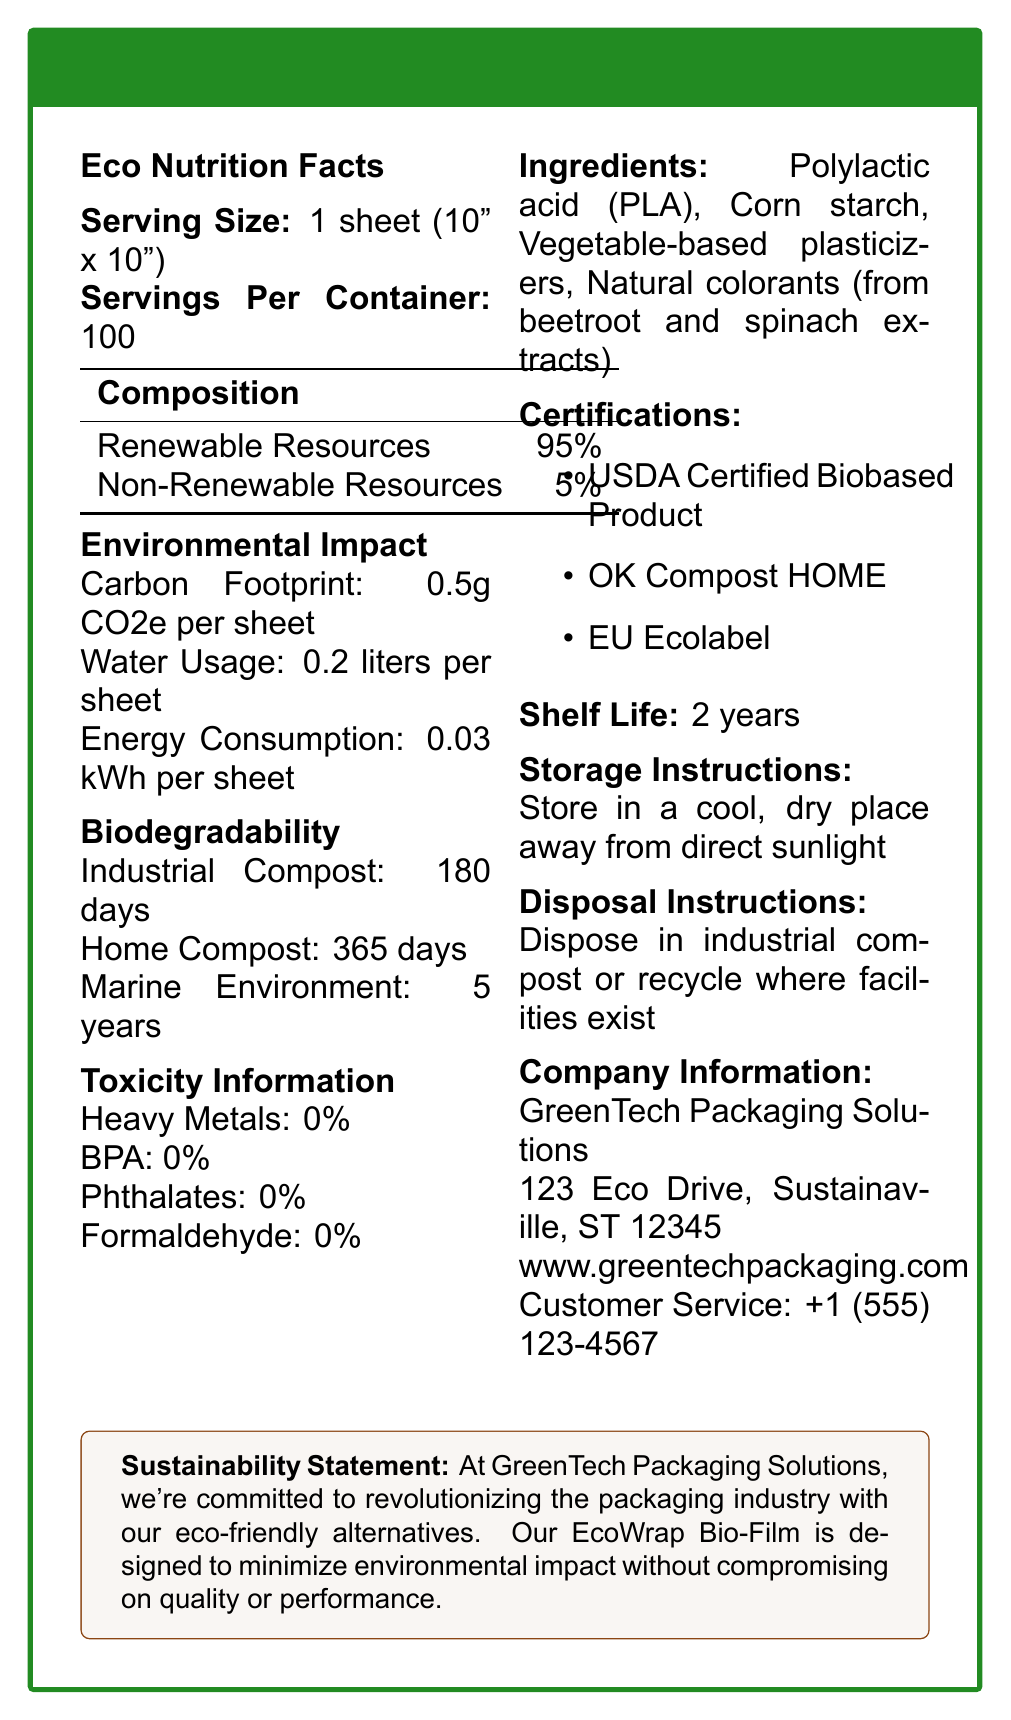what is the serving size of EcoWrap Bio-Film? The document specifies that the serving size is 1 sheet measuring 10 by 10 inches.
Answer: 1 sheet (10" x 10") how many servings are in one container? The document indicates there are 100 servings per container.
Answer: 100 what percentage of the composition comes from renewable resources? The document states that 95% of the composition is from renewable resources.
Answer: 95% what is the carbon footprint per sheet? According to the document, each sheet has a carbon footprint of 0.5 grams CO2 equivalent.
Answer: 0.5g CO2e per sheet how long does it take for EcoWrap Bio-Film to biodegrade in a home compost environment? The document mentions that it takes 365 days for the product to biodegrade in a home compost environment.
Answer: 365 days which of the following is not an ingredient in EcoWrap Bio-Film? A. Polylactic acid (PLA) B. Corn starch C. Petroleum-based plasticizers D. Natural colorants The ingredients listed in the document are Polylactic acid (PLA), Corn starch, Vegetable-based plasticizers, and Natural colorants.
Answer: C what are the toxicity levels of heavy metals in EcoWrap Bio-Film? A. 0% B. 1% C. 2% D. 5% The toxicity information in the document states that the level of heavy metals is 0%.
Answer: A does EcoWrap Bio-Film contain BPA? The document explicitly mentions that the product contains 0% BPA.
Answer: No what are the storage instructions for EcoWrap Bio-Film? The document provides these specific storage instructions.
Answer: Store in a cool, dry place away from direct sunlight describe the main purpose of the EcoWrap Bio-Film document. The document presents a comprehensive overview of EcoWrap Bio-Film, highlighting its ecological benefits, safety, and ease of use, while also providing certification details and sustainability statements from the manufacturer.
Answer: The document aims to provide detailed information about EcoWrap Bio-Film, including its composition, environmental impact, biodegradability, toxicity information, ingredients, certifications, shelf life, storage, disposal instructions, and company information, emphasizing its eco-friendly and non-toxic properties. on what date was the EcoWrap Bio-Film first manufactured? The document does not provide any information regarding the date of manufacture of EcoWrap Bio-Film.
Answer: Not enough information 